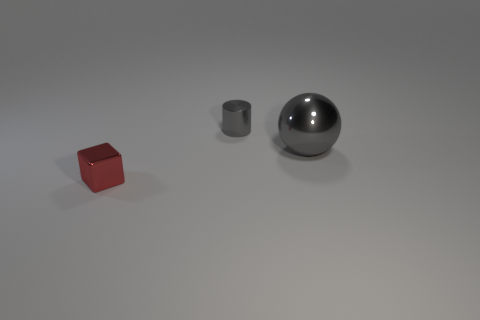Is there a large red thing made of the same material as the large ball?
Offer a terse response. No. How many gray things are either big metal spheres or tiny blocks?
Your answer should be compact. 1. Is the number of tiny red cubes that are on the right side of the cube greater than the number of big things?
Your answer should be compact. No. Do the shiny cylinder and the shiny ball have the same size?
Offer a terse response. No. The tiny cube that is made of the same material as the gray sphere is what color?
Your answer should be very brief. Red. There is a tiny object that is the same color as the big metallic ball; what shape is it?
Offer a very short reply. Cylinder. Are there the same number of small red metallic things that are in front of the big object and things on the left side of the small cylinder?
Provide a succinct answer. Yes. The thing that is in front of the gray thing to the right of the tiny gray thing is what shape?
Offer a terse response. Cube. What is the color of the cylinder that is the same size as the red thing?
Your answer should be compact. Gray. Are there the same number of big objects that are in front of the red shiny block and small cubes?
Ensure brevity in your answer.  No. 